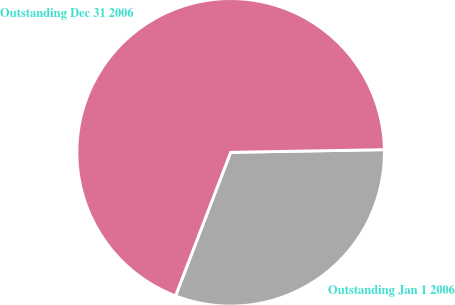Convert chart to OTSL. <chart><loc_0><loc_0><loc_500><loc_500><pie_chart><fcel>Outstanding Jan 1 2006<fcel>Outstanding Dec 31 2006<nl><fcel>31.11%<fcel>68.89%<nl></chart> 